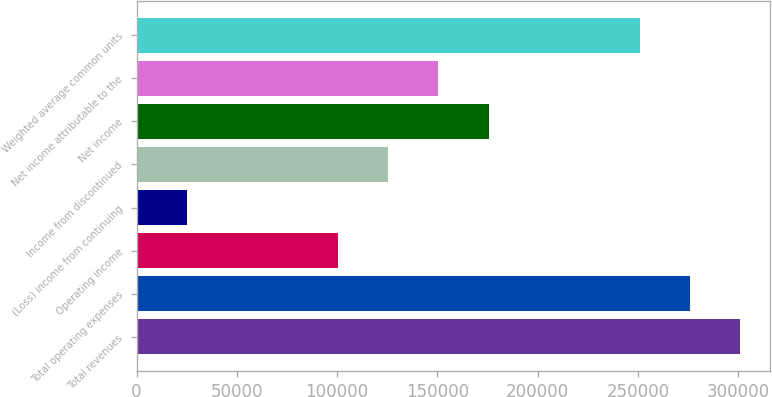<chart> <loc_0><loc_0><loc_500><loc_500><bar_chart><fcel>Total revenues<fcel>Total operating expenses<fcel>Operating income<fcel>(Loss) income from continuing<fcel>Income from discontinued<fcel>Net income<fcel>Net income attributable to the<fcel>Weighted average common units<nl><fcel>301034<fcel>275948<fcel>100345<fcel>25086.2<fcel>125431<fcel>175603<fcel>150517<fcel>250862<nl></chart> 